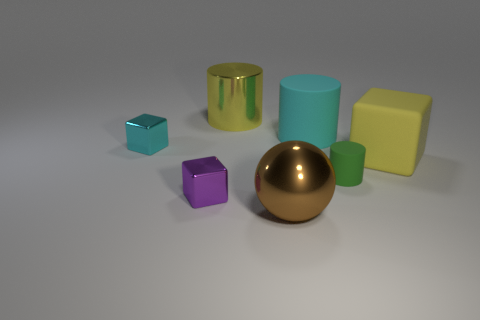How do the colors of the objects contribute to the overall aesthetic of the scene? The colors create a harmonious palette with muted pastels juxtaposed against the bold metallic sheen of the golden objects. The cool tones of the sky blue cylinder and teal cube balance against the warm yellow and purple, lending the composition a pleasant and modern visual appeal. 